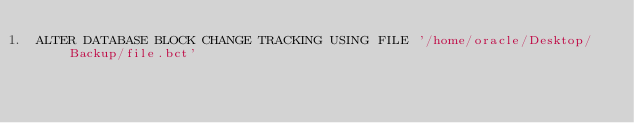Convert code to text. <code><loc_0><loc_0><loc_500><loc_500><_SQL_>ALTER DATABASE BLOCK CHANGE TRACKING USING FILE '/home/oracle/Desktop/Backup/file.bct'</code> 